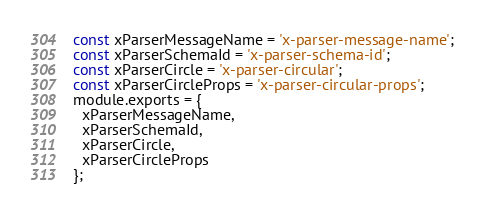Convert code to text. <code><loc_0><loc_0><loc_500><loc_500><_JavaScript_>const xParserMessageName = 'x-parser-message-name';
const xParserSchemaId = 'x-parser-schema-id';
const xParserCircle = 'x-parser-circular';
const xParserCircleProps = 'x-parser-circular-props';
module.exports = {
  xParserMessageName,
  xParserSchemaId,
  xParserCircle,
  xParserCircleProps
};</code> 